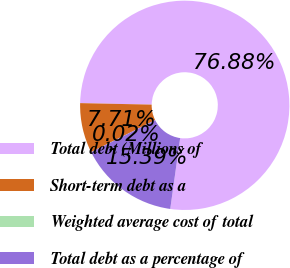Convert chart to OTSL. <chart><loc_0><loc_0><loc_500><loc_500><pie_chart><fcel>Total debt (Millions of<fcel>Short-term debt as a<fcel>Weighted average cost of total<fcel>Total debt as a percentage of<nl><fcel>76.87%<fcel>7.71%<fcel>0.02%<fcel>15.39%<nl></chart> 